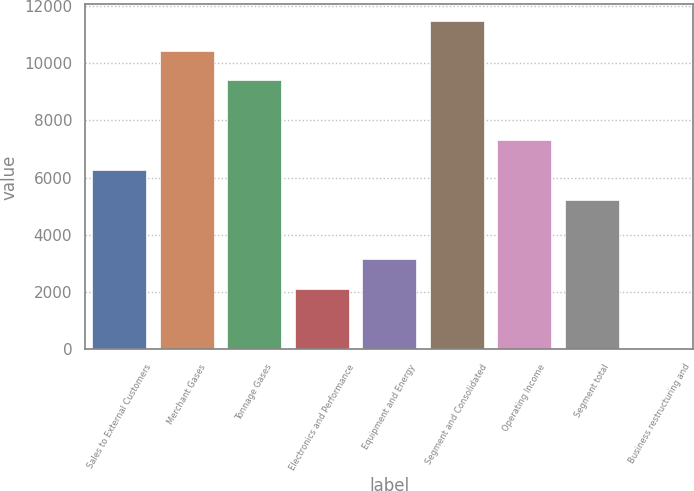<chart> <loc_0><loc_0><loc_500><loc_500><bar_chart><fcel>Sales to External Customers<fcel>Merchant Gases<fcel>Tonnage Gases<fcel>Electronics and Performance<fcel>Equipment and Energy<fcel>Segment and Consolidated<fcel>Operating Income<fcel>Segment total<fcel>Business restructuring and<nl><fcel>6268.48<fcel>10439<fcel>9396.37<fcel>2097.96<fcel>3140.59<fcel>11481.6<fcel>7311.11<fcel>5225.85<fcel>12.7<nl></chart> 